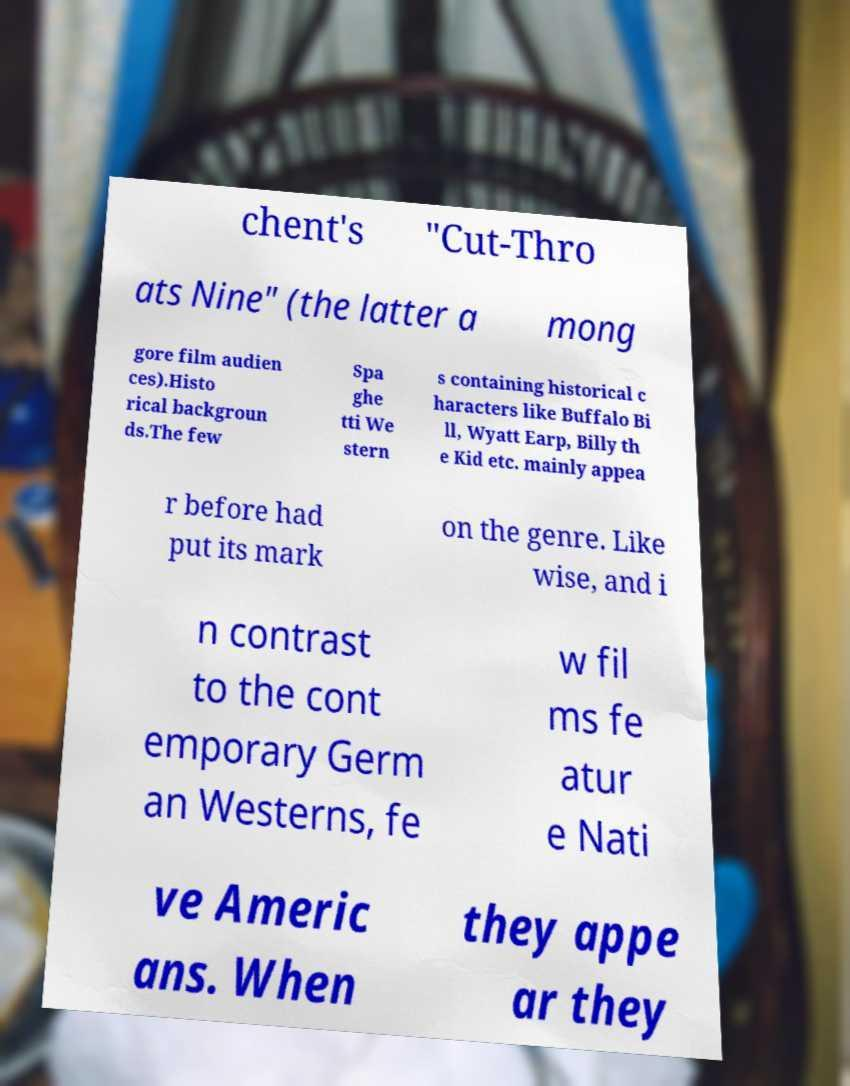Please identify and transcribe the text found in this image. chent's "Cut-Thro ats Nine" (the latter a mong gore film audien ces).Histo rical backgroun ds.The few Spa ghe tti We stern s containing historical c haracters like Buffalo Bi ll, Wyatt Earp, Billy th e Kid etc. mainly appea r before had put its mark on the genre. Like wise, and i n contrast to the cont emporary Germ an Westerns, fe w fil ms fe atur e Nati ve Americ ans. When they appe ar they 